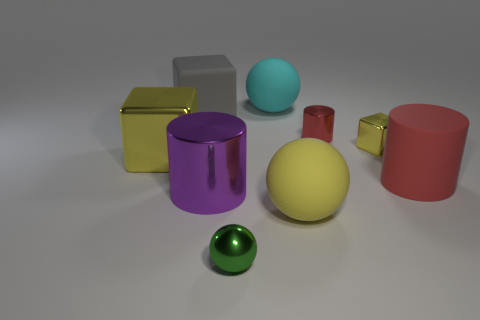There is a metal object that is the same color as the small cube; what shape is it?
Offer a very short reply. Cube. Does the tiny metallic cylinder have the same color as the large matte cylinder?
Your response must be concise. Yes. What number of things are either large gray cubes or yellow objects right of the small green ball?
Your answer should be very brief. 3. Is the number of tiny objects less than the number of big matte balls?
Keep it short and to the point. No. What is the color of the big ball that is behind the big metallic thing right of the rubber cube?
Provide a succinct answer. Cyan. There is a small thing that is the same shape as the big purple shiny thing; what material is it?
Ensure brevity in your answer.  Metal. What number of shiny things are either big blue things or large gray cubes?
Provide a short and direct response. 0. Does the large gray block that is behind the green metal thing have the same material as the block that is in front of the small yellow thing?
Provide a short and direct response. No. Are there any green metallic things?
Offer a very short reply. Yes. Do the matte object that is left of the purple metallic thing and the tiny object behind the tiny block have the same shape?
Your answer should be very brief. No. 